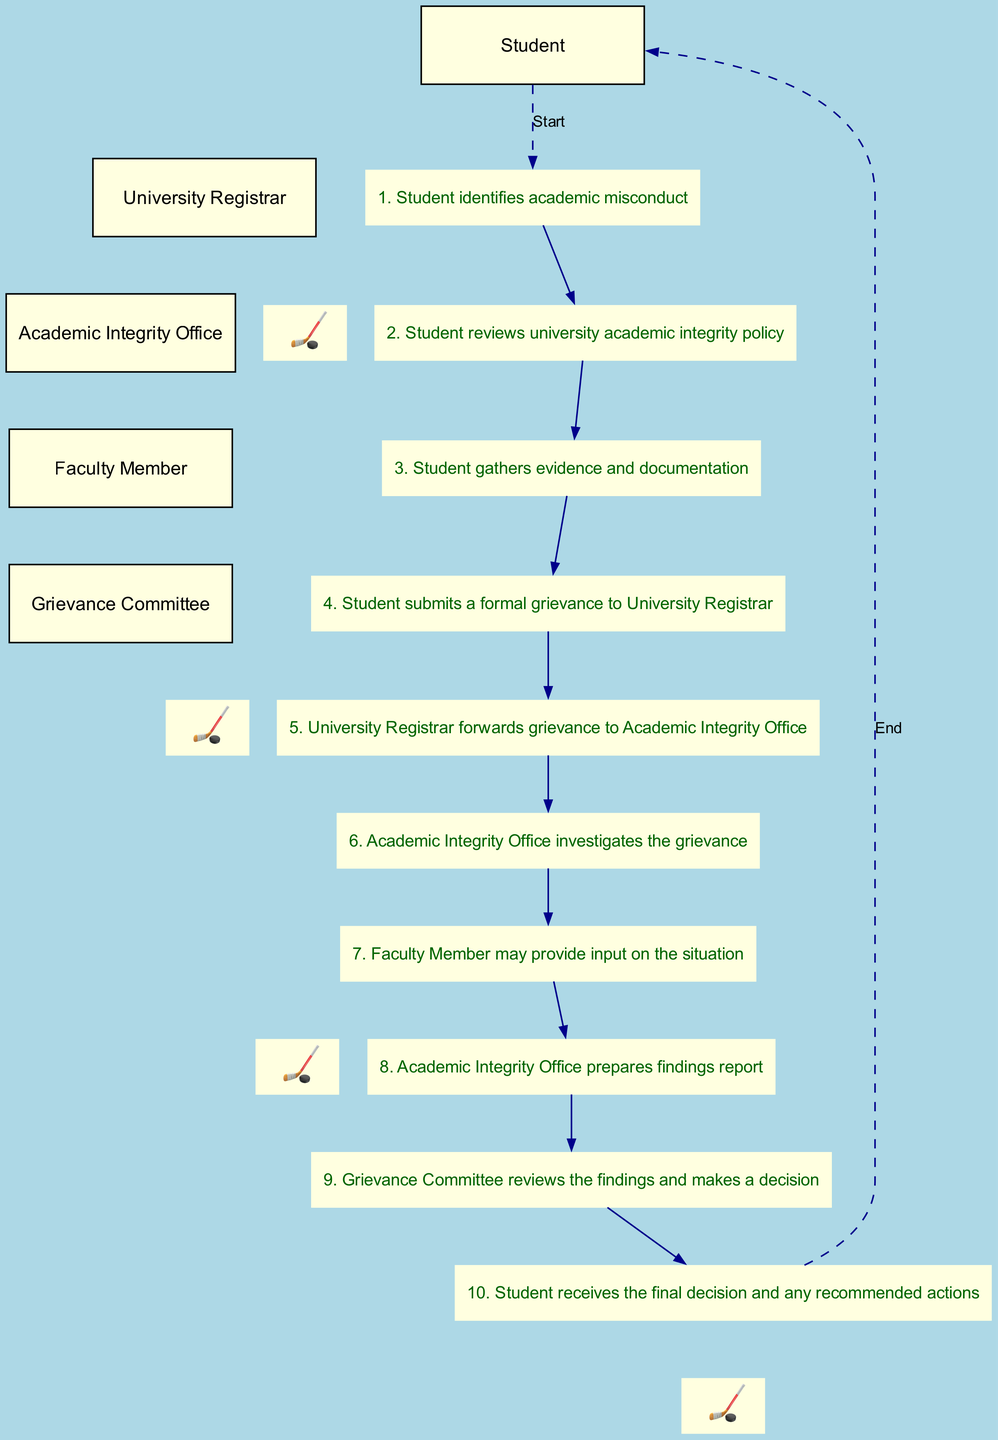What is the total number of steps in the grievance filing process? There are ten steps listed in the sequence diagram that represent the process from identifying academic misconduct to receiving the final decision.
Answer: 10 Who is the first participant in the diagram? The sequence diagram lists the participants, and the first one mentioned is the "Student."
Answer: Student Which step involves submitting a formal grievance? The action of submitting a formal grievance is described as step 4, where the student submits to the University Registrar.
Answer: 4 What action follows the submission of the formal grievance? After the grievance is submitted in step 4, the next action is step 5, where the University Registrar forwards the grievance to the Academic Integrity Office.
Answer: University Registrar forwards grievance to Academic Integrity Office How many participants are involved in this sequence diagram? The sequence diagram includes five distinct participants, which are the Student, University Registrar, Academic Integrity Office, Faculty Member, and Grievance Committee.
Answer: 5 Which step includes the Faculty Member's input? Step 7 describes the action where the Faculty Member may provide input on the situation. This is a crucial point as it shows involvement beyond just the Student and Registrar.
Answer: Faculty Member may provide input on the situation What does the Academic Integrity Office do in step 8? In step 8, the Academic Integrity Office prepares a findings report as a result of their investigation into the grievance.
Answer: Academic Integrity Office prepares findings report How does the diagram signify the start of the grievance process? The beginning of the process is signified by a dashed line from the Student to the first step, indicating the start of the grievance filing steps.
Answer: Start What is the final outcome that the Student receives? The final decision along with any recommended actions is provided to the Student in step 10, marking the conclusion of the grievance process.
Answer: Student receives the final decision and any recommended actions 